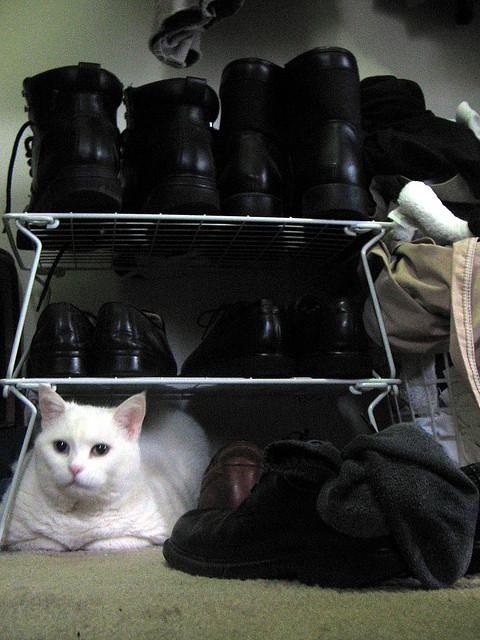What color is the cat?
Quick response, please. White. Are these men's shoes?
Write a very short answer. Yes. Does the cat like shoes?
Concise answer only. Yes. 